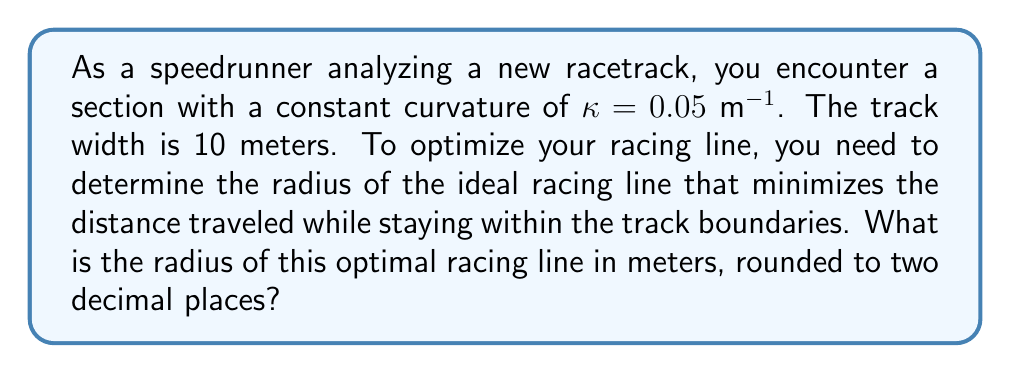Can you solve this math problem? To solve this problem, we need to consider the geometry of the racetrack and the concept of racing line optimization. Here's a step-by-step approach:

1. The curvature $\kappa$ is the inverse of the radius $R$. For the track's center line:
   $$R_{center} = \frac{1}{\kappa} = \frac{1}{0.05} = 20\text{ m}$$

2. The track width is 10 meters, so the inner and outer radii are:
   $$R_{inner} = R_{center} - 5 = 15\text{ m}$$
   $$R_{outer} = R_{center} + 5 = 25\text{ m}$$

3. The optimal racing line will be somewhere between these two radii. To minimize the distance traveled, we want to maximize the radius while staying within the track.

4. The ideal racing line is not simply the outermost possible line. Instead, it's a compromise between a larger radius (for higher speed) and a shorter path.

5. For a constant curvature track, the optimal racing line can be approximated using the geometric mean of the inner and outer radii:
   $$R_{optimal} = \sqrt{R_{inner} \cdot R_{outer}}$$

6. Substituting the values:
   $$R_{optimal} = \sqrt{15 \cdot 25} = \sqrt{375} \approx 19.37\text{ m}$$

7. Rounding to two decimal places gives us 19.37 m.

This racing line allows for the highest possible speed through the curve while minimizing the total distance traveled.

[asy]
import geometry;

real R = 20;
real w = 10;
real Ri = R - w/2;
real Ro = R + w/2;
real Ropt = sqrt(Ri*Ro);

path track = Arc((0,0), R, 0, 90);
path inner = Arc((0,0), Ri, 0, 90);
path outer = Arc((0,0), Ro, 0, 90);
path optimal = Arc((0,0), Ropt, 0, 90);

draw(track, blue);
draw(inner, blue+dashed);
draw(outer, blue+dashed);
draw(optimal, red);

label("Center line", (R,R), NE, blue);
label("Optimal line", (Ropt,Ropt), SE, red);
label("Inner boundary", (Ri,Ri), NW, blue);
label("Outer boundary", (Ro,Ro), SE, blue);

dot((0,0), L="Center of curvature");
[/asy]
Answer: 19.37 m 